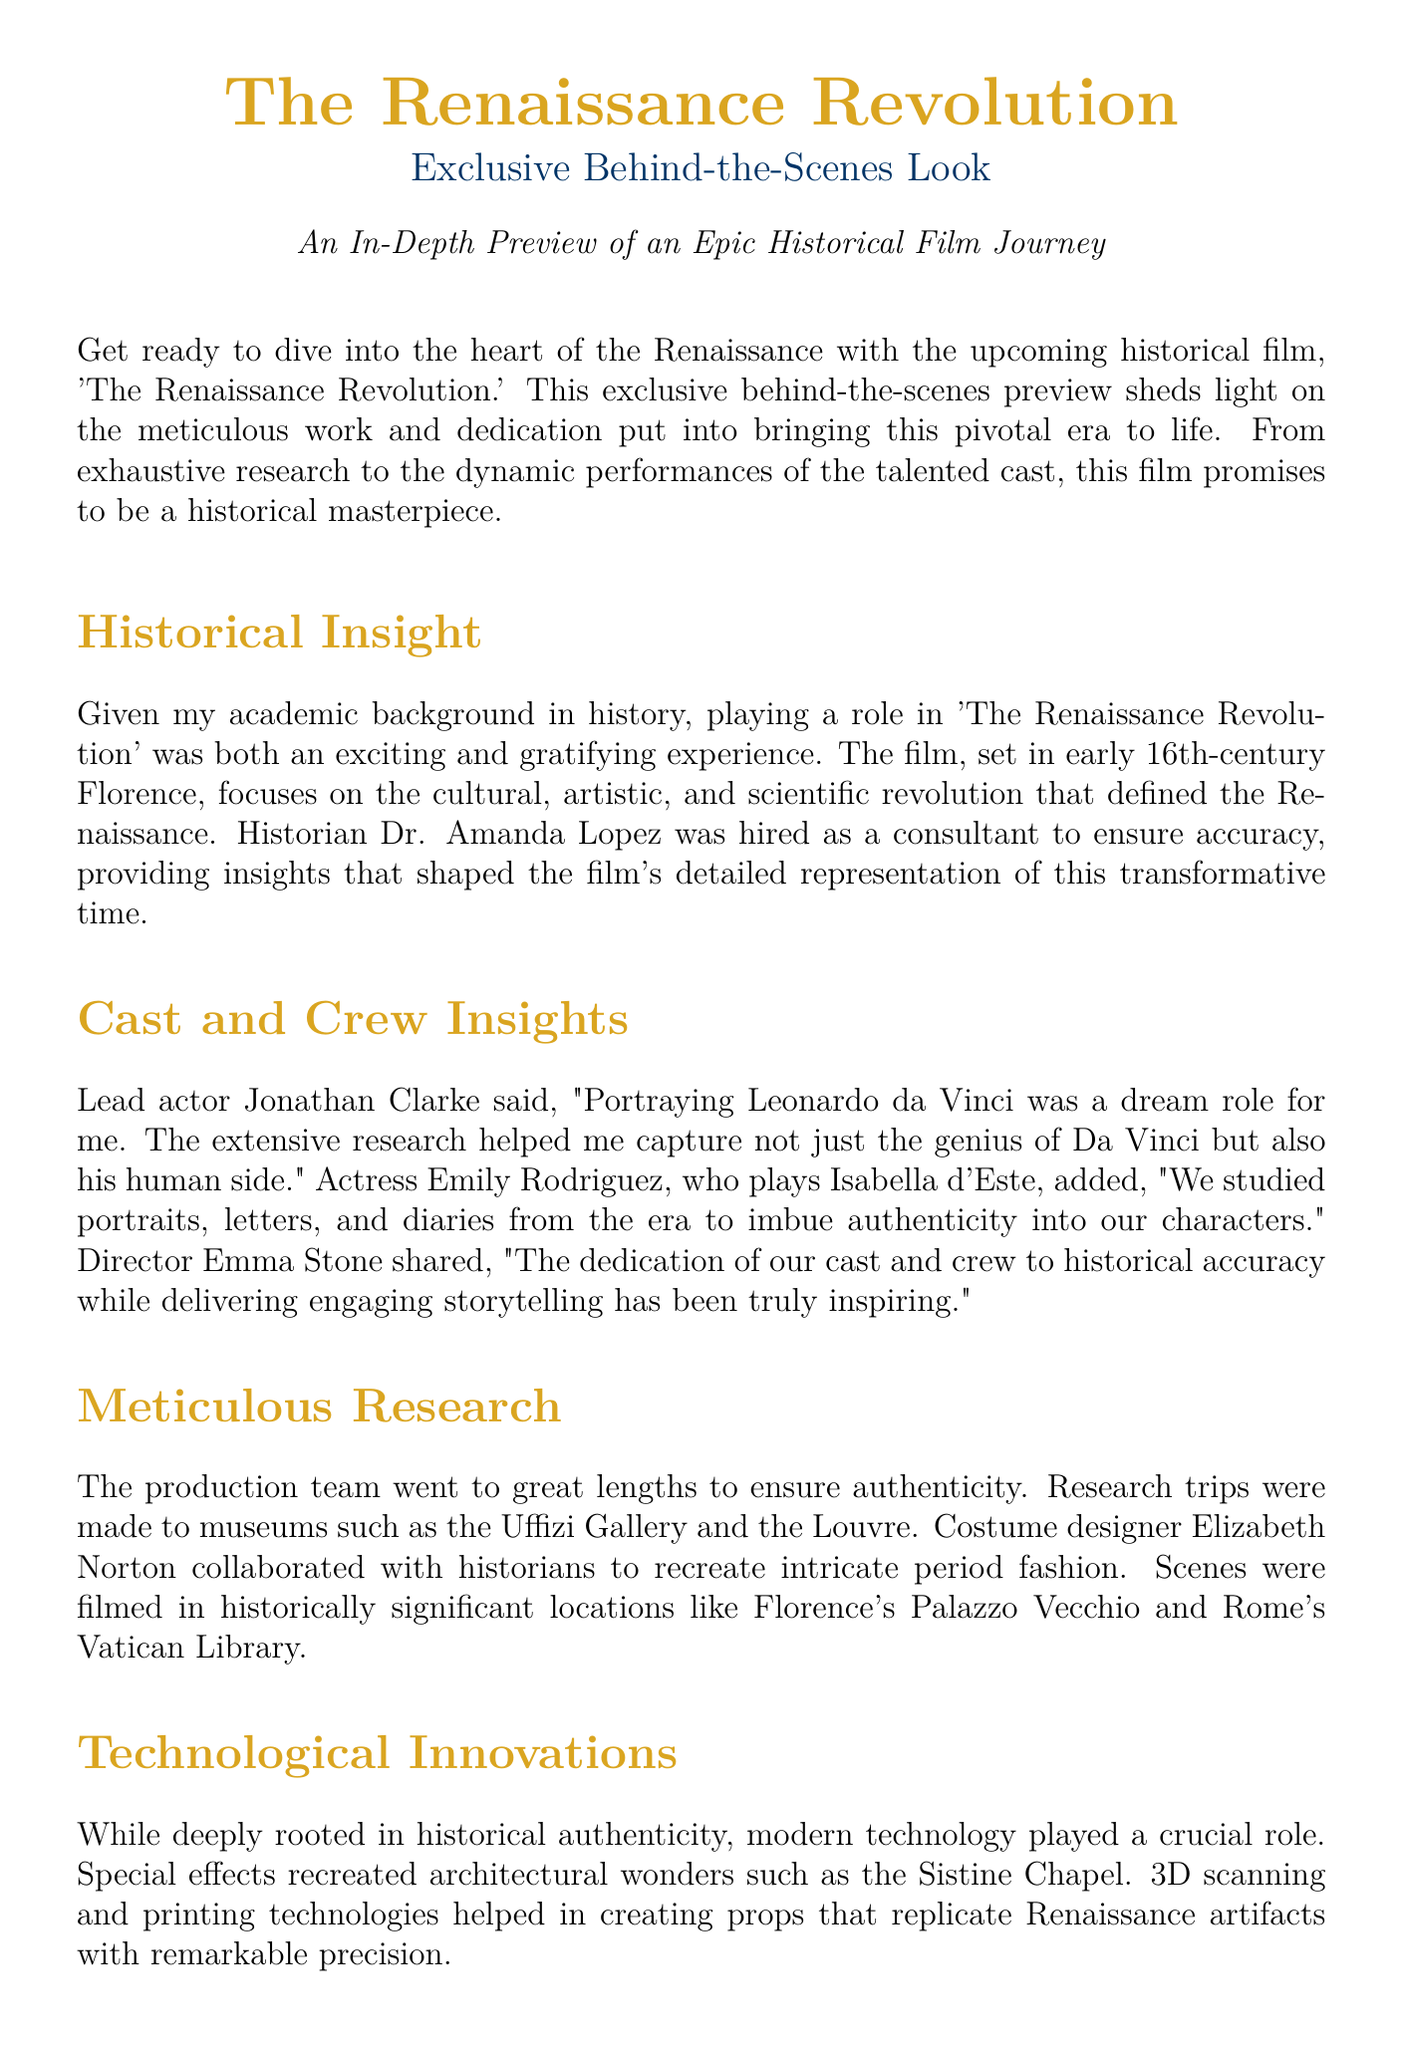What is the title of the film? The title of the film is explicitly mentioned in the document as 'The Renaissance Revolution.'
Answer: 'The Renaissance Revolution' Who is the lead actor portraying Leonardo da Vinci? The lead actor's name is directly stated in the document as Jonathan Clarke.
Answer: Jonathan Clarke Which historical period does the film focus on? The document specifies that the film focuses on the early 16th-century Renaissance period.
Answer: early 16th-century Renaissance Who collaborated with the costume designer to ensure historical accuracy? The costume designer worked with historians, as mentioned in the document.
Answer: historians What significant location is mentioned where scenes were filmed? The document lists Florence's Palazzo Vecchio as one of the historically significant locations for filming.
Answer: Palazzo Vecchio Which modern technology was used to recreate architectural wonders? The document indicates that special effects were used to recreate architectural wonders.
Answer: special effects What is the purpose of Dr. Amanda Lopez's role in the film? The document explains that Dr. Amanda Lopez was hired as a consultant to ensure accuracy in the film.
Answer: ensure accuracy How did Emily Rodriguez describe the method of preparing for her role? The document notes that she and other cast members studied portraits, letters, and diaries from the era.
Answer: studied portraits, letters, and diaries What does the film aim to do beyond entertainment? The document states that the film also educates viewers about the Renaissance era.
Answer: educates viewers 